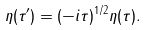Convert formula to latex. <formula><loc_0><loc_0><loc_500><loc_500>\eta ( \tau ^ { \prime } ) = ( - i \tau ) ^ { 1 / 2 } \eta ( \tau ) .</formula> 